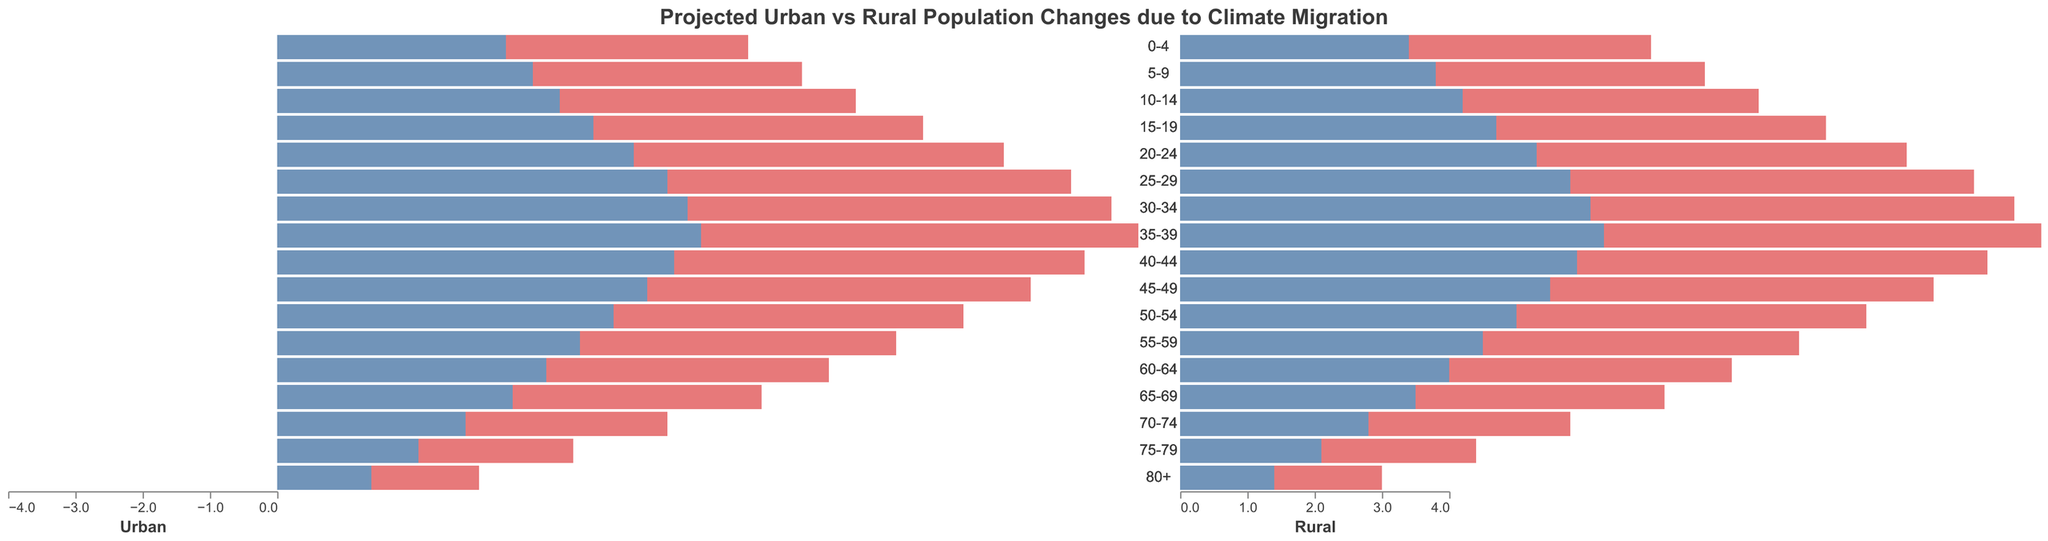What age group shows the highest population in urban females? According to the figure, the age group with the highest positive value for urban females is 35-39, with a value of 3.7.
Answer: 35-39 Which gender has a greater population in the 20-24 age group in rural areas? In the 20-24 age group for rural areas, comparing -2.3 for males and 2.2 for females, the population of rural females is greater.
Answer: Female What’s the total population of urban males in the 25-29 and 30-34 age groups? For urban males, sum the values for 25-29 (-3.5) and 30-34 (-3.7). The total is -3.5 + (-3.7) = -7.2.
Answer: -7.2 What is the difference in the populations between rural males and urban males in the 0-4 age group? Compare the values for rural males (-1.5) and urban males (-2.1) in the 0-4 age group: -1.5 - (-2.1) = 2.1 - 1.5 = 0.6.
Answer: 0.6 How does the population of urban females compare to rural females in the 50-54 age group? The figure indicates the populations for urban females and rural females in the 50-54 age group are 3.0 and 2.0 respectively. Urban females have a higher population than rural females by 1.0.
Answer: Urban females are higher by 1.0 Which age group has the closest populations between urban males and rural males? By examining the negative values of populations, the age group 0-4 shows urban males (-2.1) and rural males (-1.5) having the closest values. The difference is 0.6.
Answer: 0-4 Which area (urban or rural) shows a larger overall population for the 70-74 age group? Comparing the values for rural males (-1.2) and females (1.1) against urban males (-1.8) and females (1.7), the rural total is -1.2 + 1.1 = -0.1, while the urban total is -1.8 + 1.7 = -0.1.
Answer: Equal What is the average value of the population of urban males in the age groups from 10-14 to 15-19? Sum the values for urban males in 10-14 (-2.5) and 15-19 (-2.8), then divide by 2. The average is (-2.5 - 2.8)/2 = -2.65.
Answer: -2.65 Which gender in the rural area shows a larger population in the aged 80+ group? The plots reflect that rural females have a population of 0.5, whereas rural males have a population of -0.6. Rural females have a higher population.
Answer: Female 